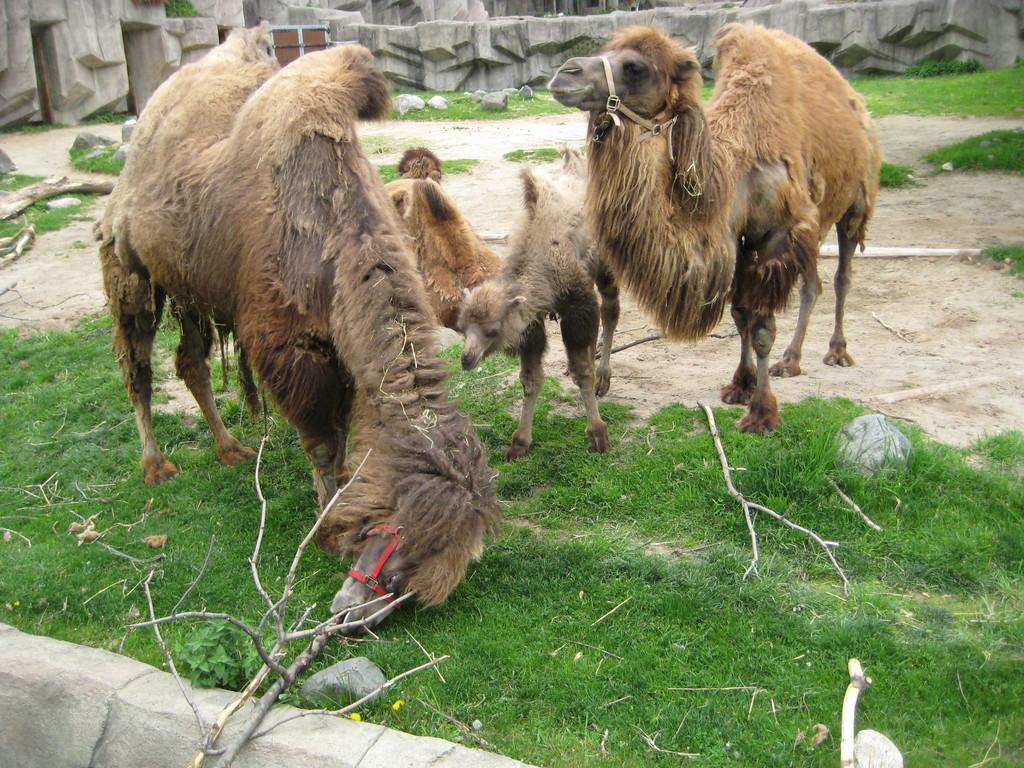Could you give a brief overview of what you see in this image? In this image I see animals which are of brown in color and I see the grass and I see few sticks. In the background I see the rocks. 